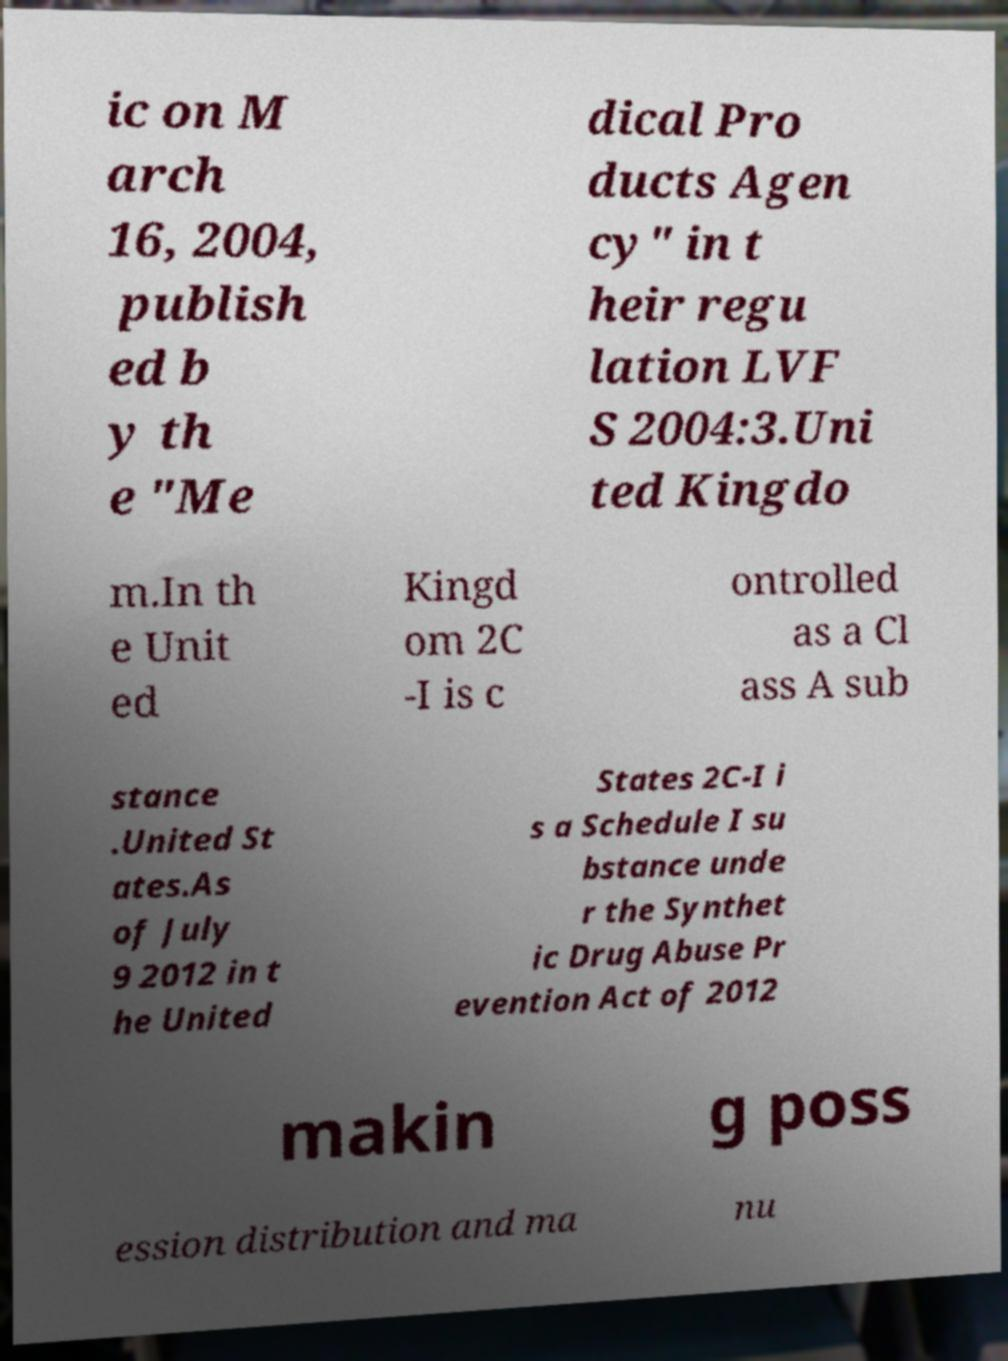Could you extract and type out the text from this image? ic on M arch 16, 2004, publish ed b y th e "Me dical Pro ducts Agen cy" in t heir regu lation LVF S 2004:3.Uni ted Kingdo m.In th e Unit ed Kingd om 2C -I is c ontrolled as a Cl ass A sub stance .United St ates.As of July 9 2012 in t he United States 2C-I i s a Schedule I su bstance unde r the Synthet ic Drug Abuse Pr evention Act of 2012 makin g poss ession distribution and ma nu 